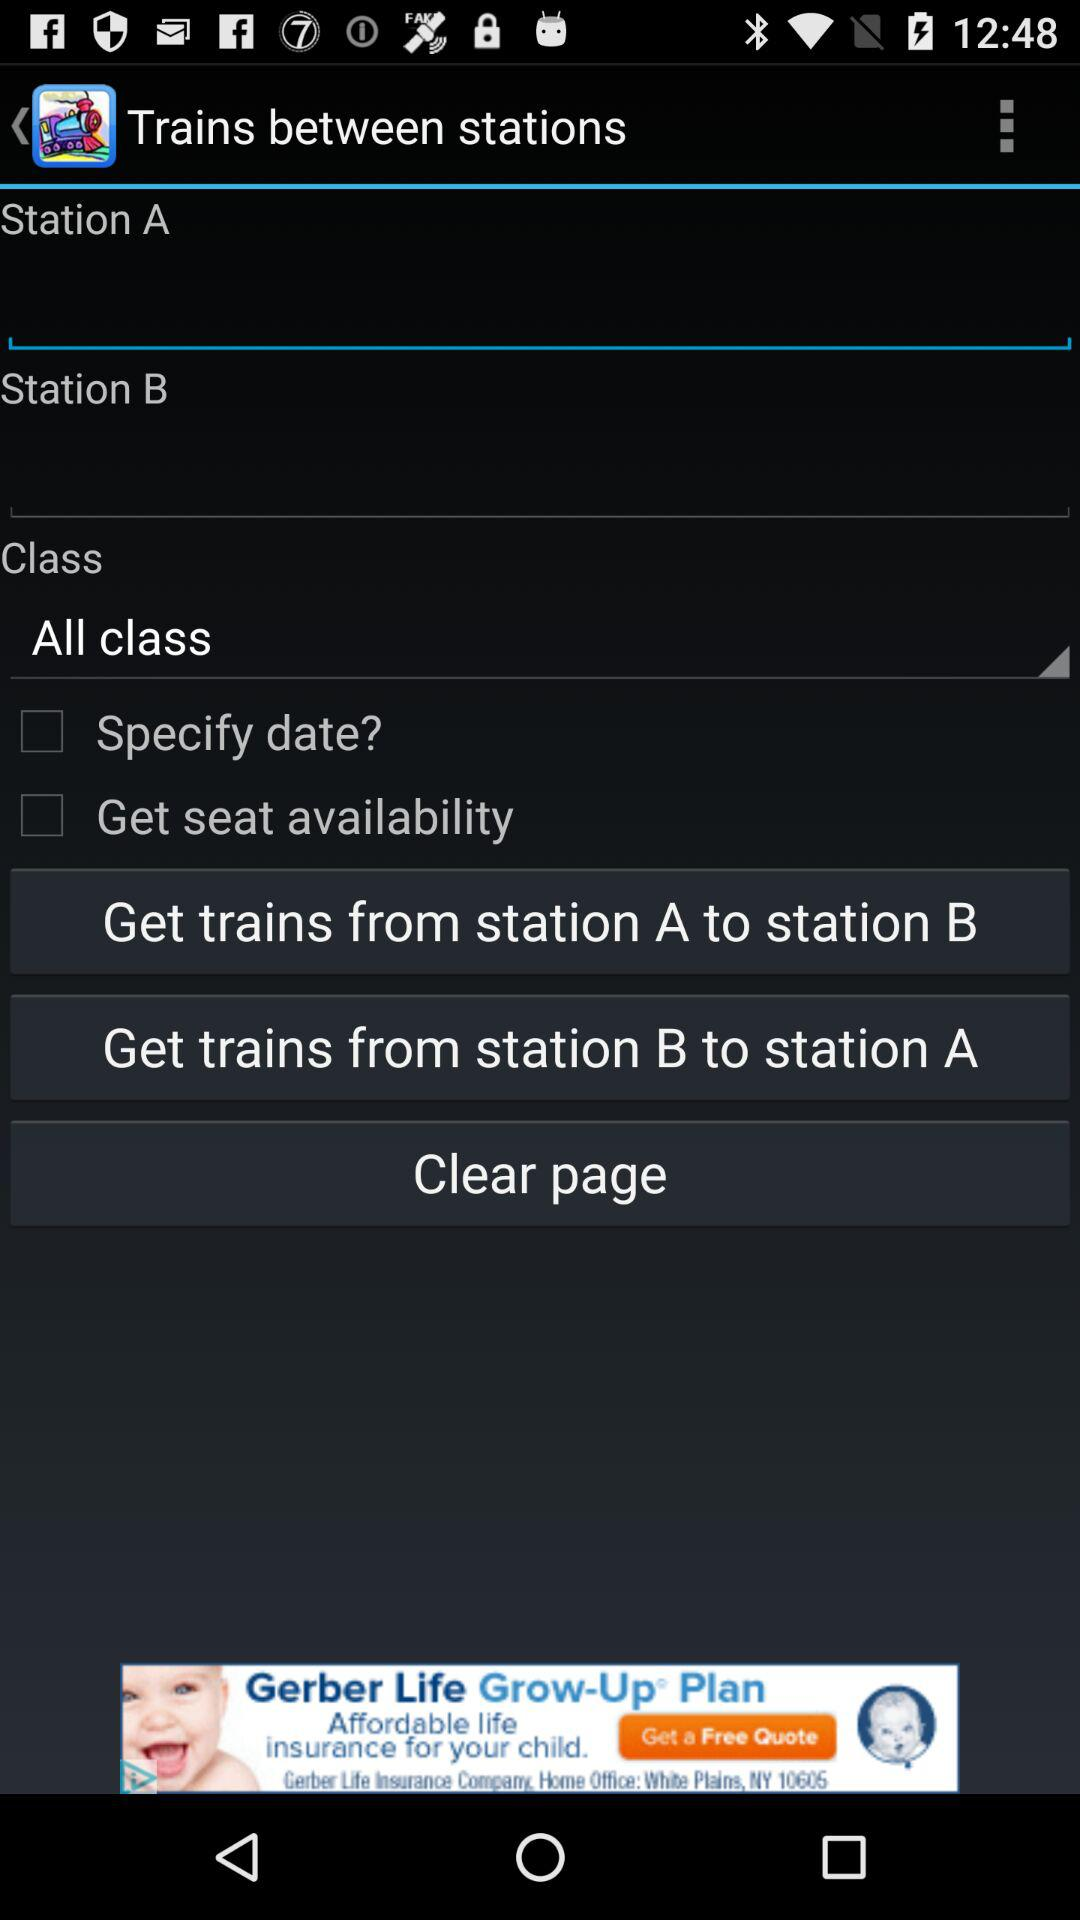From which station can we get a train? You get a trains from "station A to Station B" and "station B to Station A". 